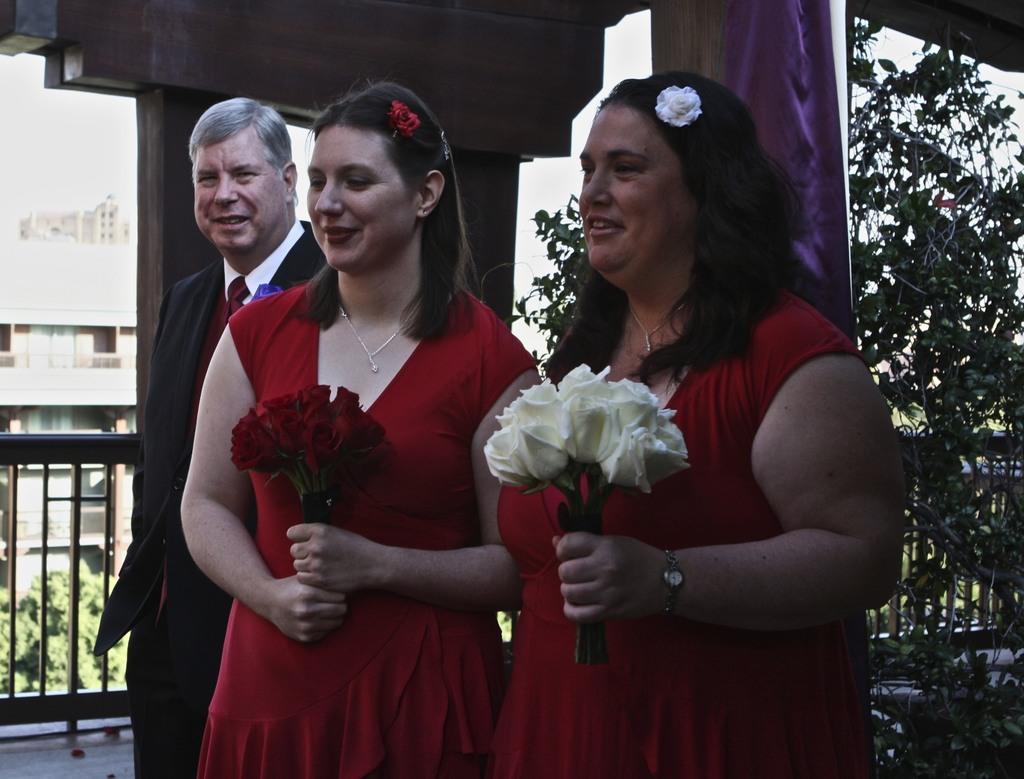Can you describe this image briefly? In this image, we can see a few people. Among them, some people are holding flowers. We can see the ground and the fence. We can see some plants and buildings. 